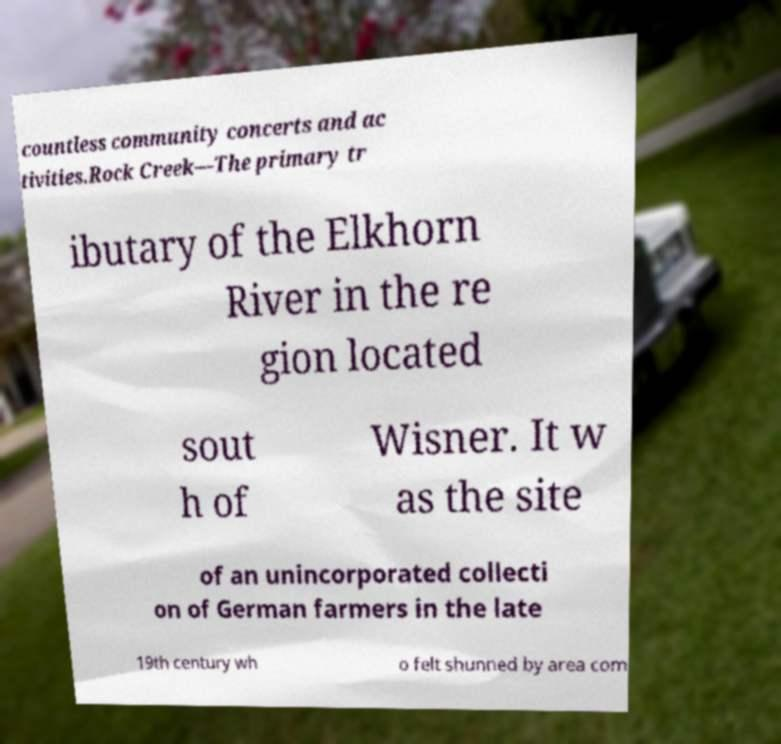Please read and relay the text visible in this image. What does it say? countless community concerts and ac tivities.Rock Creek—The primary tr ibutary of the Elkhorn River in the re gion located sout h of Wisner. It w as the site of an unincorporated collecti on of German farmers in the late 19th century wh o felt shunned by area com 